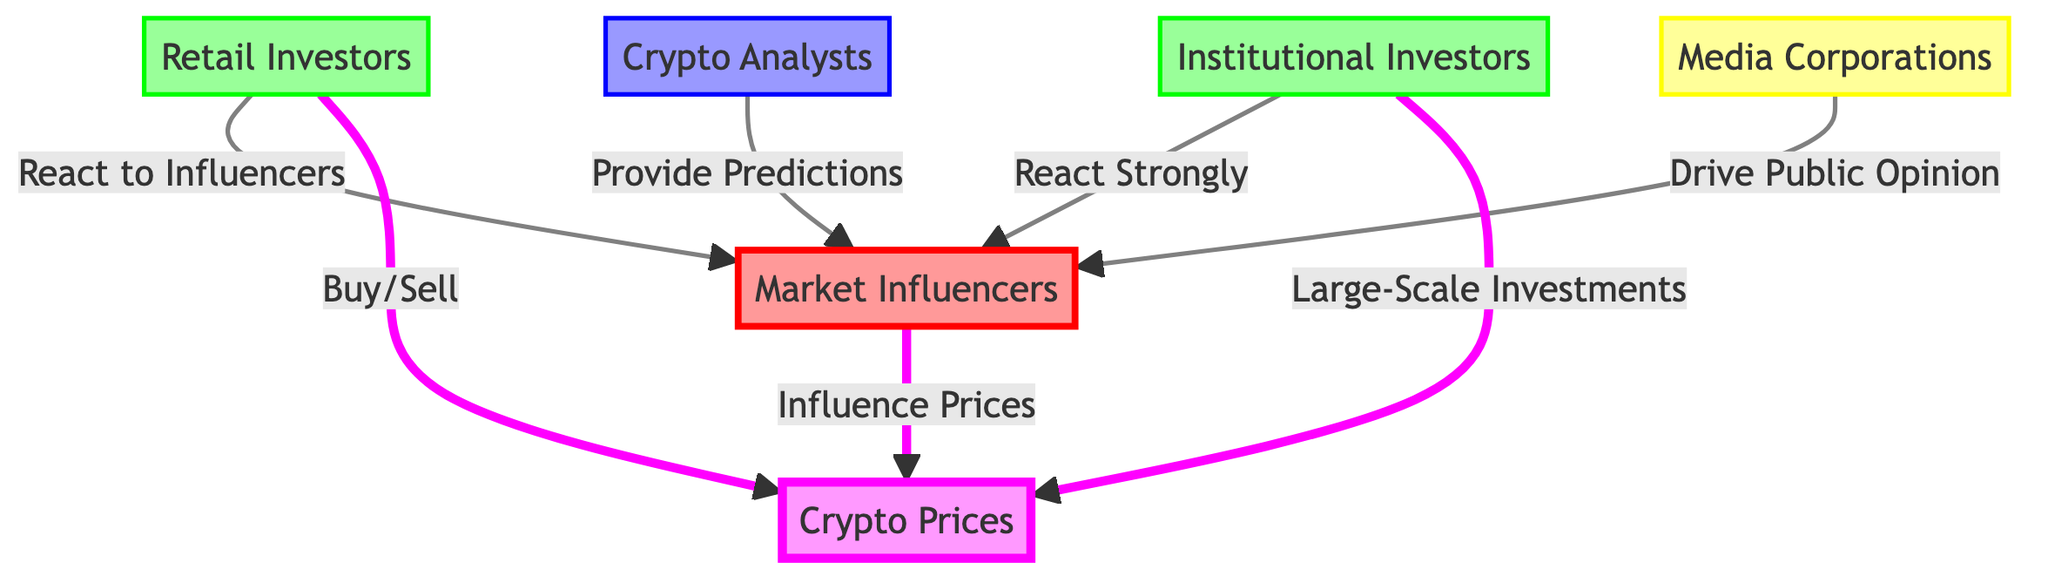What is the main input that influences crypto prices? According to the diagram, "Market Influencers" are shown as the primary entity directly influencing the "Crypto Prices" node.
Answer: Market Influencers How many types of investors are depicted in the diagram? There are two distinct types of investors shown in the diagram: "Retail Investors" and "Institutional Investors," totaling to two.
Answer: 2 What do retail investors do in relation to market influencers? The diagram states that "Retail Investors" react to "Market Influencers," indicating a direct relationship where retail investors respond to the influences from the market.
Answer: React to Influencers Which group is shown to react most strongly to influencers? The diagram specifies that "Institutional Investors" are depicted as reacting strongly to "Market Influencers," indicating their high sensitivity to these external impacts.
Answer: React Strongly What role do media corporations play in this diagram? The diagram highlights that "Media Corporations" drive public opinion regarding "Market Influencers," showing their influence in shaping the narrative around cryptocurrency.
Answer: Drive Public Opinion How do crypto analysts contribute according to the diagram? "Crypto Analysts" are shown to provide predictions regarding "Market Influencers," suggesting their role in forecasting market movements based on influencer activity.
Answer: Provide Predictions What happens when retail investors buy or sell? The flow in the diagram indicates that retail investors' actions of buying or selling directly impact "Crypto Prices," highlighting their influence on market volatility through their trades.
Answer: Buy/Sell What significant action do institutional investors take regarding crypto prices? The diagram illustrates that "Institutional Investors" engage in large-scale investments, which directly affect "Crypto Prices," indicating their capacity to alter market conditions significantly.
Answer: Large-Scale Investments Which entities have direct connections to price volatility? The diagram shows that "Market Influencers," "Retail Investors," and "Institutional Investors" all have direct relationships impacting "Crypto Prices," highlighting their collective influence on price volatility.
Answer: Market Influencers, Retail Investors, Institutional Investors 